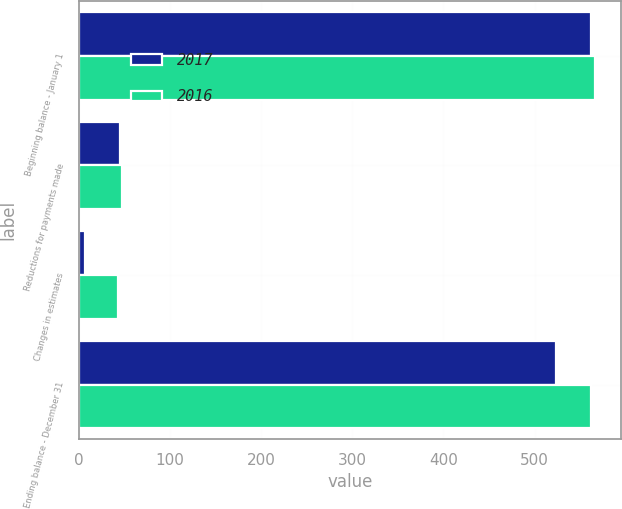Convert chart to OTSL. <chart><loc_0><loc_0><loc_500><loc_500><stacked_bar_chart><ecel><fcel>Beginning balance - January 1<fcel>Reductions for payments made<fcel>Changes in estimates<fcel>Ending balance - December 31<nl><fcel>2017<fcel>562<fcel>45<fcel>7<fcel>524<nl><fcel>2016<fcel>566<fcel>47<fcel>43<fcel>562<nl></chart> 